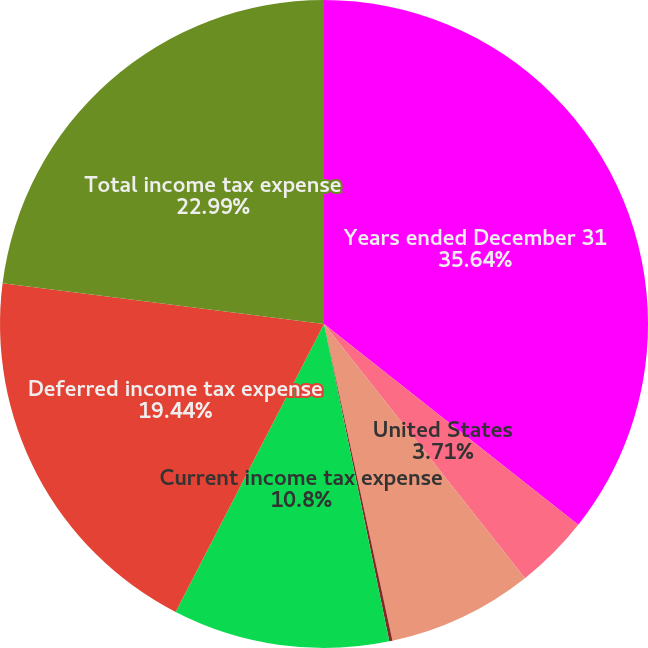Convert chart to OTSL. <chart><loc_0><loc_0><loc_500><loc_500><pie_chart><fcel>Years ended December 31<fcel>United States<fcel>Other nations<fcel>States (US)<fcel>Current income tax expense<fcel>Deferred income tax expense<fcel>Total income tax expense<nl><fcel>35.64%<fcel>3.71%<fcel>7.26%<fcel>0.16%<fcel>10.8%<fcel>19.44%<fcel>22.99%<nl></chart> 